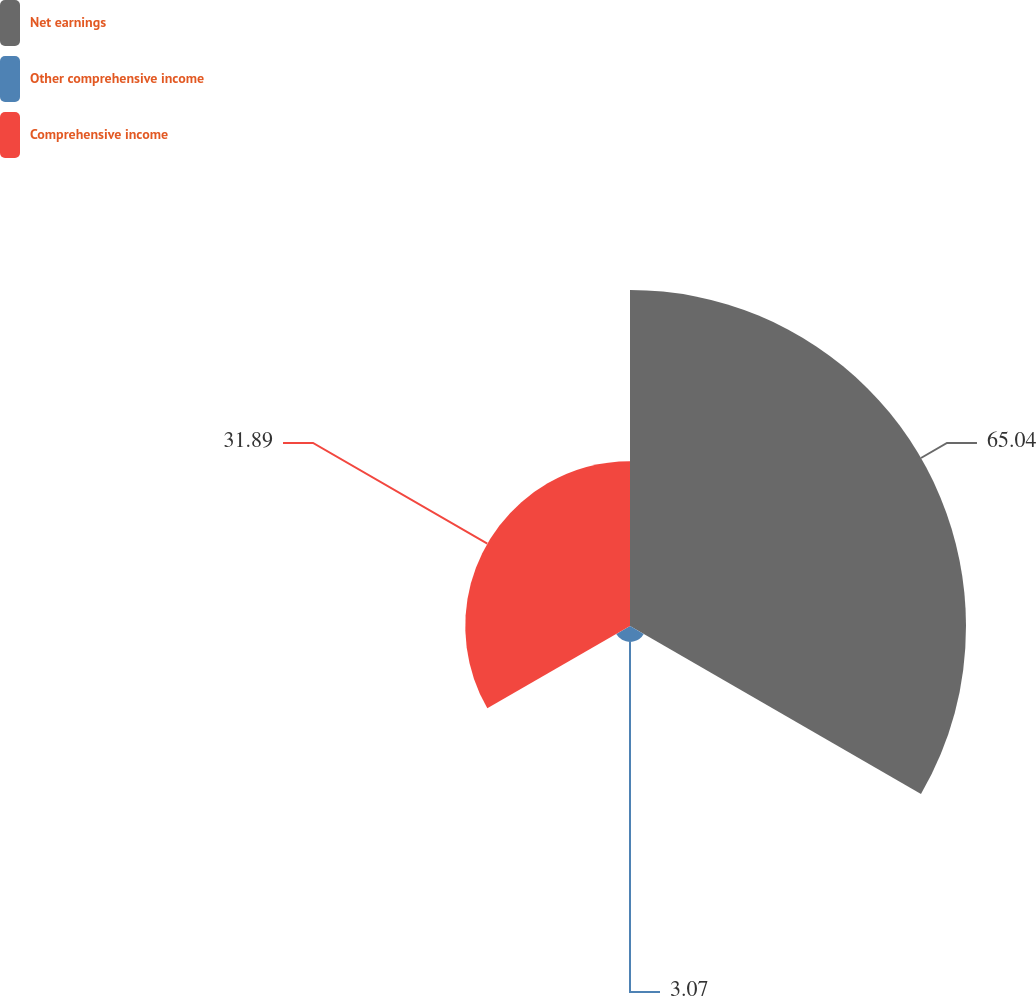<chart> <loc_0><loc_0><loc_500><loc_500><pie_chart><fcel>Net earnings<fcel>Other comprehensive income<fcel>Comprehensive income<nl><fcel>65.04%<fcel>3.07%<fcel>31.89%<nl></chart> 